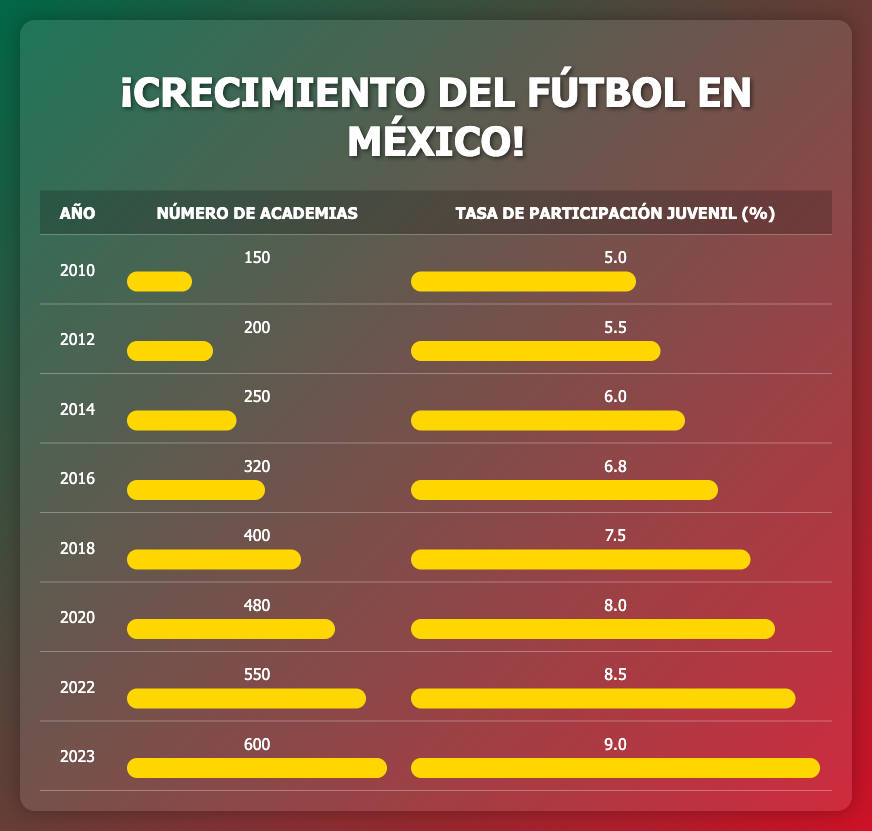What was the number of football academies in 2014? The table shows a specific row corresponding to the year 2014. In that row, the number of academies listed is 250.
Answer: 250 What was the youth participation rate in 2022? Looking at the row for the year 2022 in the table, the youth participation rate is listed as 8.5%.
Answer: 8.5% How many more academies were there in 2020 compared to 2010? The number of academies in 2020 is 480, and in 2010 it is 150. To find the difference, subtract: 480 - 150 = 330.
Answer: 330 What is the average youth participation rate from 2010 to 2023? To calculate the average, add the youth participation rates from each year (5.0 + 5.5 + 6.0 + 6.8 + 7.5 + 8.0 + 8.5 + 9.0 = 56.3) and divide by the total number of years (8). Hence, 56.3 / 8 = 7.0375.
Answer: 7.04 Was the number of academies greater in 2023 than in 2016? According to the table, the number of academies in 2023 is 600 while in 2016 it is 320. Since 600 is greater than 320, the answer is yes.
Answer: Yes How much did the youth participation rate increase from 2014 to 2023? The youth participation rate in 2014 was 6.0%, and in 2023 it is 9.0%. The increase is found by subtracting: 9.0 - 6.0 = 3.0%.
Answer: 3.0% In which year was the youth participation rate 8.0%? The table reveals that the youth participation rate reached 8.0% in the year 2020.
Answer: 2020 How many academies were there in the year with the highest youth participation rate? Analyzing the table, the highest youth participation rate is 9.0% in 2023, where the number of academies is listed as 600.
Answer: 600 